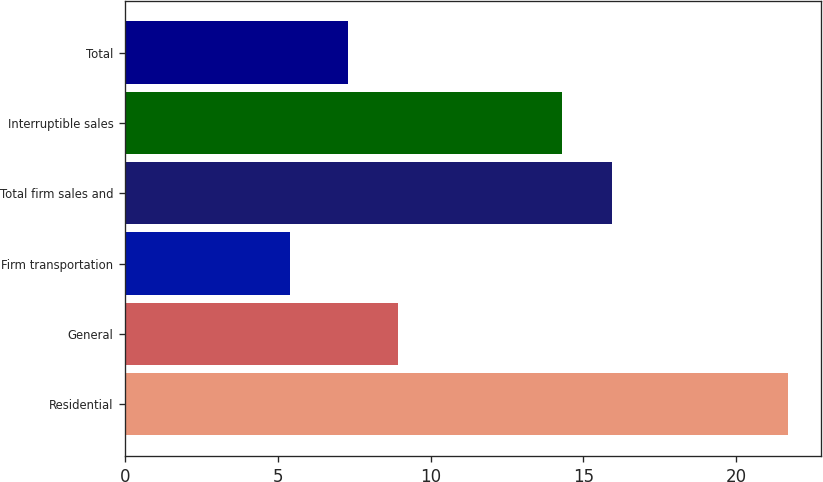Convert chart. <chart><loc_0><loc_0><loc_500><loc_500><bar_chart><fcel>Residential<fcel>General<fcel>Firm transportation<fcel>Total firm sales and<fcel>Interruptible sales<fcel>Total<nl><fcel>21.7<fcel>8.93<fcel>5.4<fcel>15.93<fcel>14.3<fcel>7.3<nl></chart> 